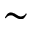Convert formula to latex. <formula><loc_0><loc_0><loc_500><loc_500>\sim</formula> 